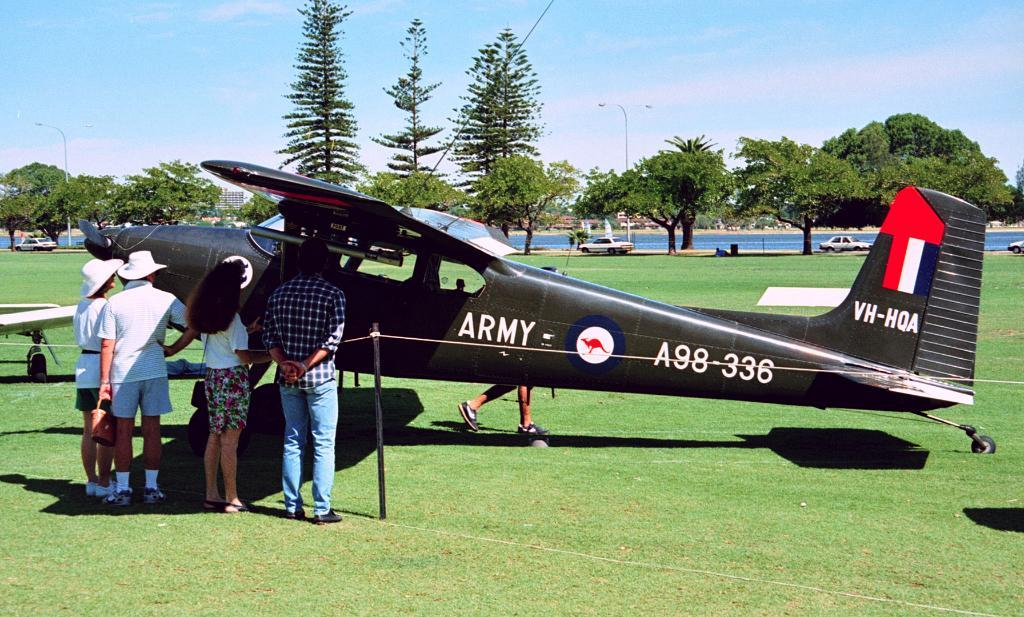<image>
Relay a brief, clear account of the picture shown. An small black aircraft with ARMY and A98-336 printed on the side and VH-HQA on it's tail being viewed by a small crowd. 